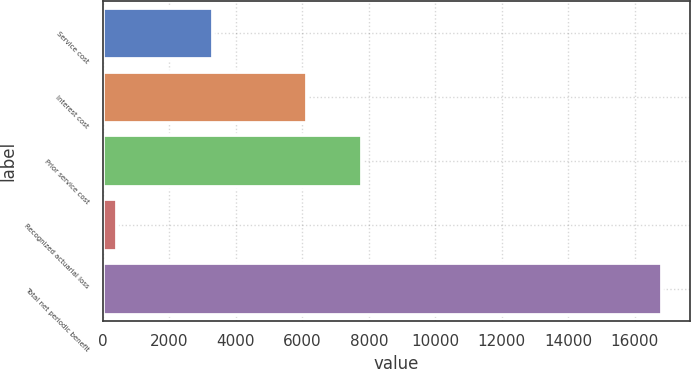Convert chart to OTSL. <chart><loc_0><loc_0><loc_500><loc_500><bar_chart><fcel>Service cost<fcel>Interest cost<fcel>Prior service cost<fcel>Recognized actuarial loss<fcel>Total net periodic benefit<nl><fcel>3320<fcel>6148<fcel>7786.7<fcel>428<fcel>16815<nl></chart> 